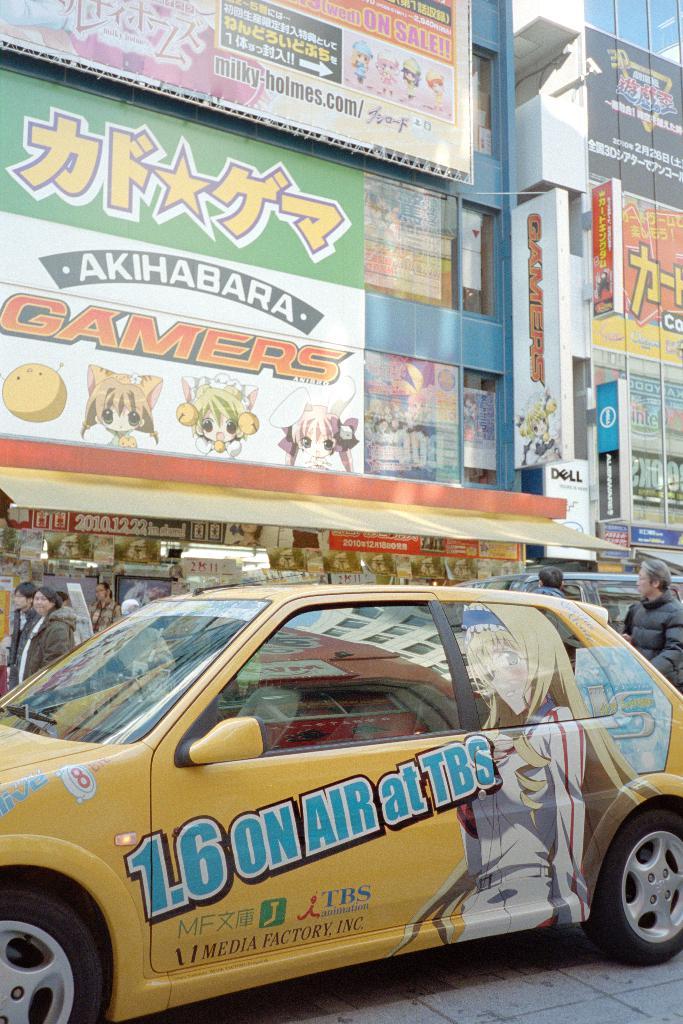1.6 is on air where?
Offer a terse response. Tbs. What color is the car?
Keep it short and to the point. Answering does not require reading text in the image. 